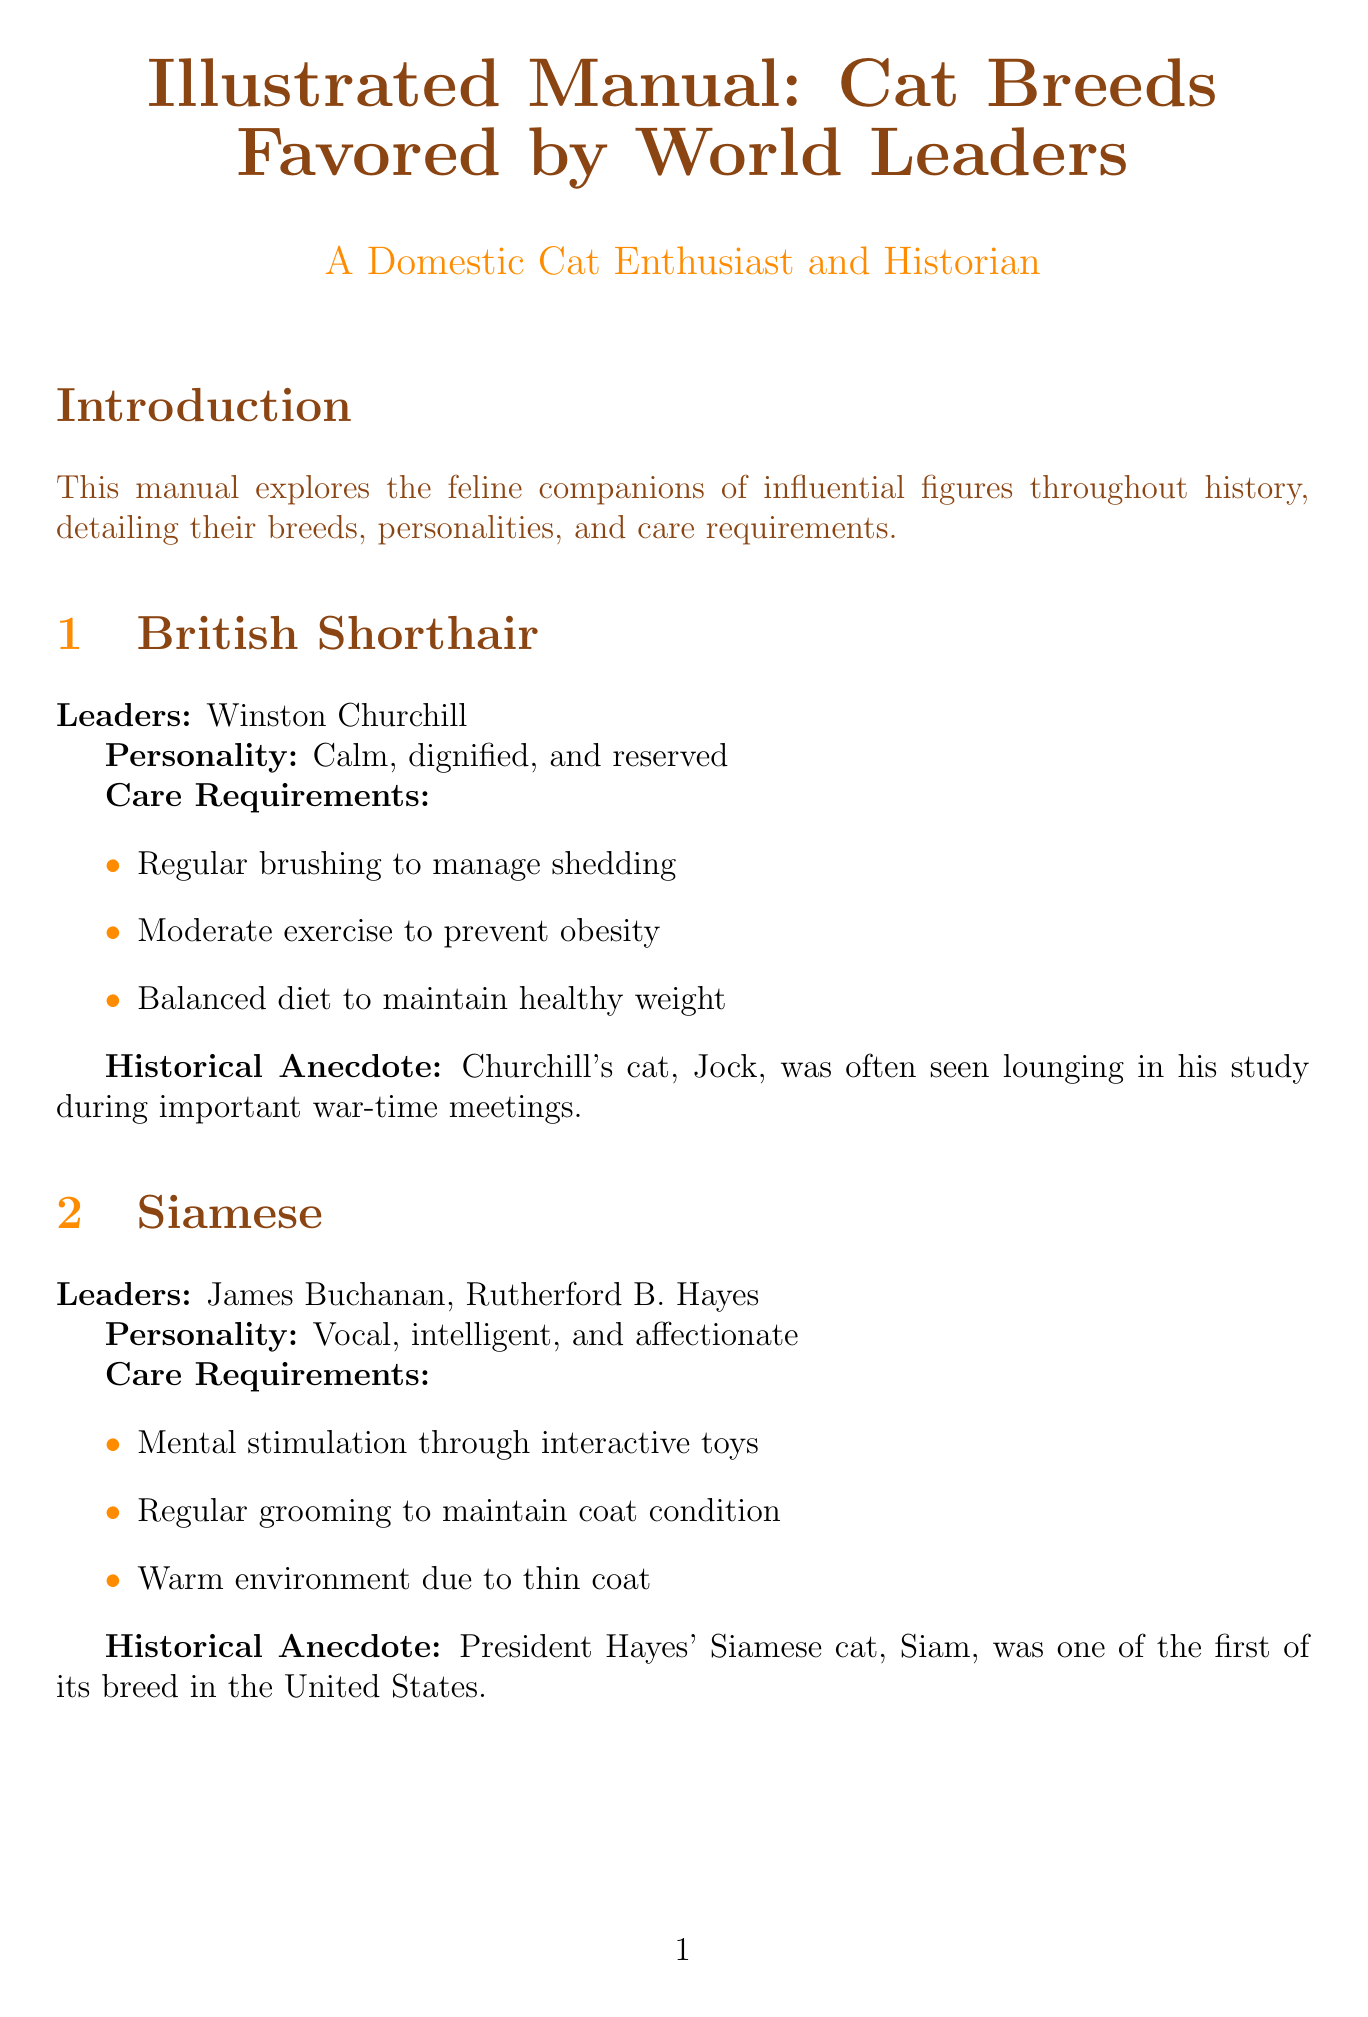What breed was favored by Winston Churchill? The document mentions that Winston Churchill favored the British Shorthair breed.
Answer: British Shorthair Which breed is described as vocal, intelligent, and affectionate? The Siamese breed is specifically described with those personality traits in the document.
Answer: Siamese How many leaders are associated with the Persian breed? The document states that the Persian breed is associated with only one leader, Queen Victoria.
Answer: One What is a care requirement for the Abyssinian? The document lists several care requirements, one of which is a high-quality protein-rich diet.
Answer: High-quality protein-rich diet What unique trait does the Russian Blue have in relation to its owners? The document notes that the Russian Blue is loyal to its owners but shy with strangers.
Answer: Loyal to owners Which president had a Maine Coon named India 'Willie' Bush? This information is specifically mentioned in the document, identifying George W. Bush.
Answer: George W. Bush What care requirement is common across the Persian breed? The document specifies daily grooming to prevent matting as a care requirement for the Persian breed.
Answer: Daily grooming What feline quality contributed to Queen Victoria's fondness for Persians? The document indicates Queen Victoria's love for Persians helped popularize the breed.
Answer: Popularize the breed What general care tip involves a routine action for pet health? The document suggests scheduling regular veterinary check-ups as a general care tip.
Answer: Regular veterinary check-ups 